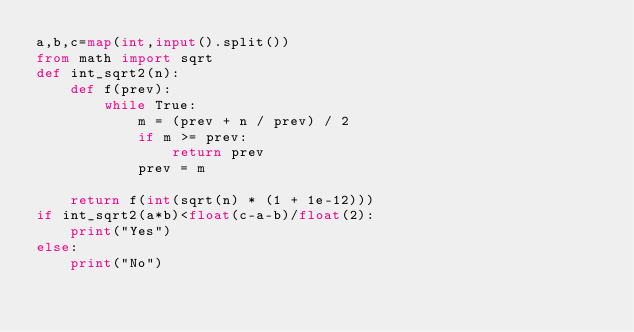<code> <loc_0><loc_0><loc_500><loc_500><_Python_>a,b,c=map(int,input().split())
from math import sqrt
def int_sqrt2(n):
    def f(prev):
        while True:
            m = (prev + n / prev) / 2
            if m >= prev:
                return prev
            prev = m
    
    return f(int(sqrt(n) * (1 + 1e-12)))
if int_sqrt2(a*b)<float(c-a-b)/float(2):
    print("Yes")
else:
    print("No")
</code> 